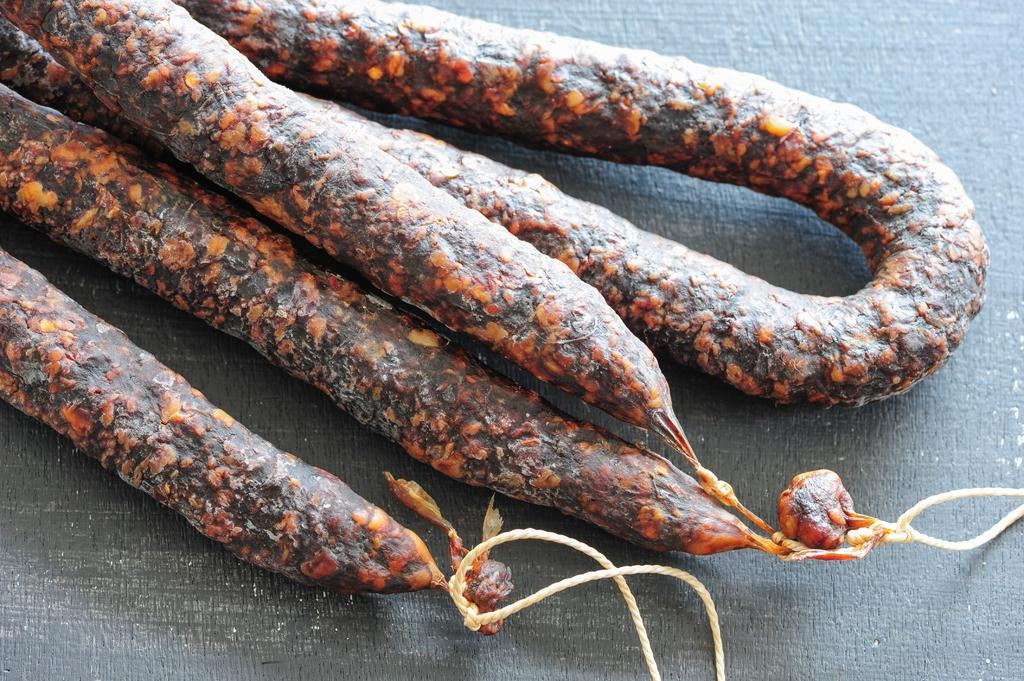What type of food is visible in the image? There are salami rolls in the image. What type of tree can be seen in the image? There is no tree present in the image; it only features salami rolls. 